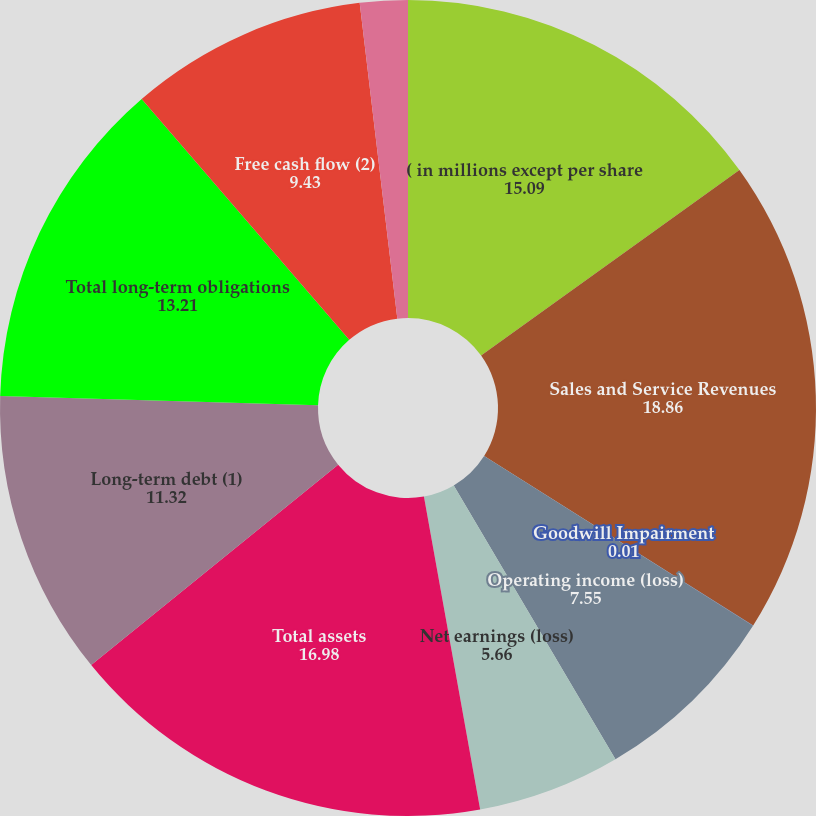Convert chart. <chart><loc_0><loc_0><loc_500><loc_500><pie_chart><fcel>( in millions except per share<fcel>Sales and Service Revenues<fcel>Goodwill Impairment<fcel>Operating income (loss)<fcel>Net earnings (loss)<fcel>Total assets<fcel>Long-term debt (1)<fcel>Total long-term obligations<fcel>Free cash flow (2)<fcel>Basic earnings (loss) per<nl><fcel>15.09%<fcel>18.86%<fcel>0.01%<fcel>7.55%<fcel>5.66%<fcel>16.98%<fcel>11.32%<fcel>13.21%<fcel>9.43%<fcel>1.89%<nl></chart> 